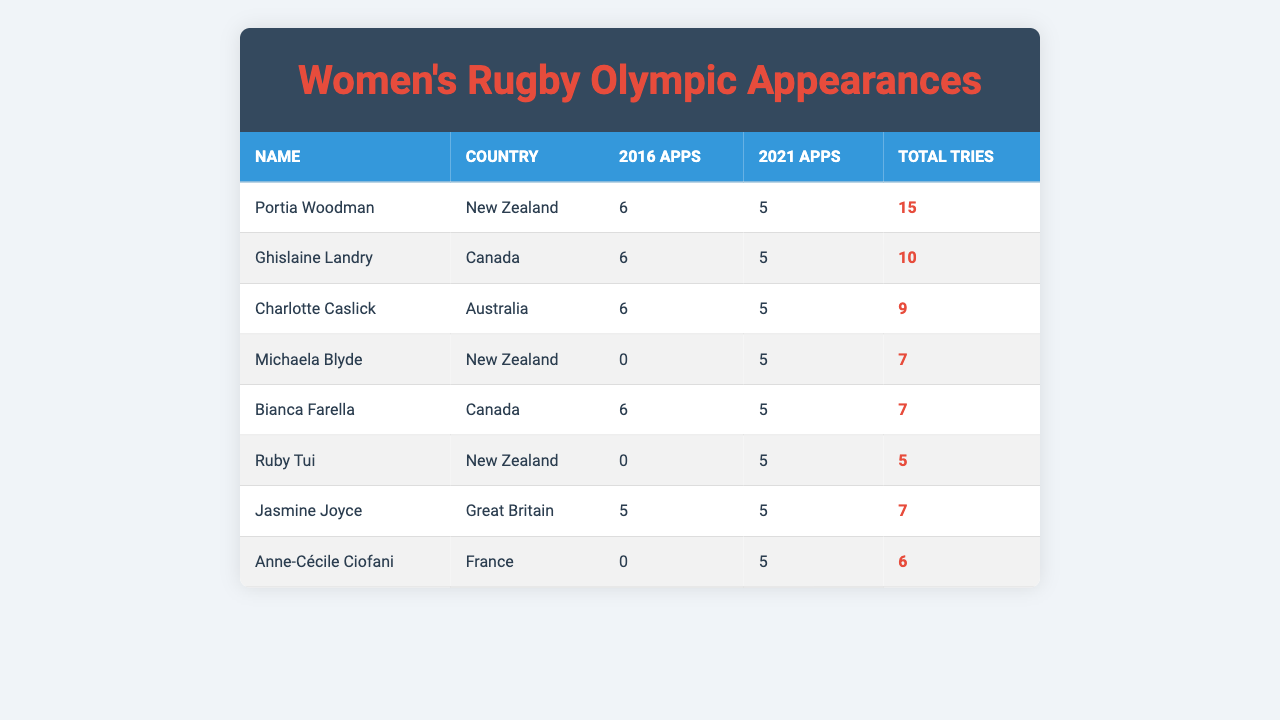What is the total number of appearances by Portia Woodman in the Olympic Games? Portia Woodman has 6 appearances in 2016 and 5 in 2021. Adding these gives 6 + 5 = 11 appearances in total.
Answer: 11 Who had the highest number of tries among the players listed? Portia Woodman has the highest tries with a total of 15. This is identified by comparing the "Total Tries" column.
Answer: Portia Woodman Which player did not appear in the 2016 Olympic Games? Michaela Blyde, Ruby Tui, and Anne-Cécile Ciofani all have 0 appearances listed for 2016. This can be confirmed by checking the 2016 appearances for each player.
Answer: Michaela Blyde, Ruby Tui, Anne-Cécile Ciofani What is the total appearance count for Canadian players in the Olympics? The Canadian players are Ghislaine Landry and Bianca Farella. Both had 6 appearances in 2016 and 5 in 2021. Adding them gives (6 + 5) + (6 + 5) = 22 total appearances.
Answer: 22 How many players had the same number of appearances in both Olympic years? There are 4 players listed with 5 appearances in both years: Ghislaine Landry, Charlotte Caslick, Jasmine Joyce, and Bianca Farella. This is determined by comparing the appearances in 2016 and 2021 for each player.
Answer: 4 Which country had the most players listed in the table? New Zealand has 3 players listed: Portia Woodman, Michaela Blyde, and Ruby Tui. This is confirmed by counting the entries for each country.
Answer: New Zealand What is the average number of tries scored by players from Great Britain? Jasmine Joyce is the only player from Great Britain with 7 tries. Since there's only one player, the average is simply 7.
Answer: 7 What was the difference in total appearances for Michaela Blyde between the years 2016 and 2021? Michaela Blyde had 0 appearances in 2016 and 5 in 2021. The difference is 5 - 0 = 5.
Answer: 5 Is it true that all players from Canada had the same number of appearances in both Olympic Games? Yes, both Ghislaine Landry and Bianca Farella had 6 appearances in 2016 and 5 in 2021, indicating they had the same number of appearances. Thus, the statement is true.
Answer: True Which player scored the least number of tries in the 2021 Games? Ruby Tui scored the least with 5 tries in 2021. This is determined by looking at the "Total Tries" column for the year 2021.
Answer: Ruby Tui 